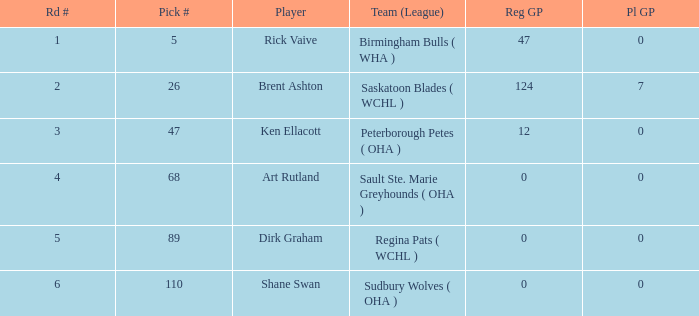What is the number of rounds for choices under 5? 0.0. 